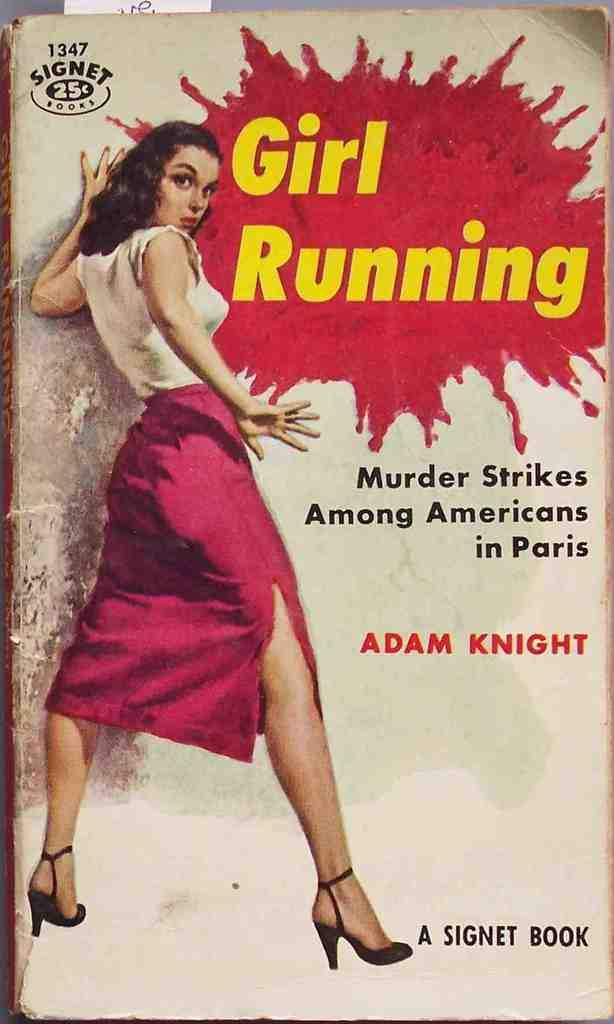<image>
Present a compact description of the photo's key features. An old book with the title Girl running 